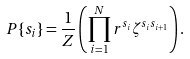Convert formula to latex. <formula><loc_0><loc_0><loc_500><loc_500>P \{ s _ { i } \} = \frac { 1 } { Z } \left ( { \prod _ { i = 1 } ^ { N } r ^ { s _ { i } } \zeta ^ { s _ { i } s _ { i + 1 } } } \right ) .</formula> 